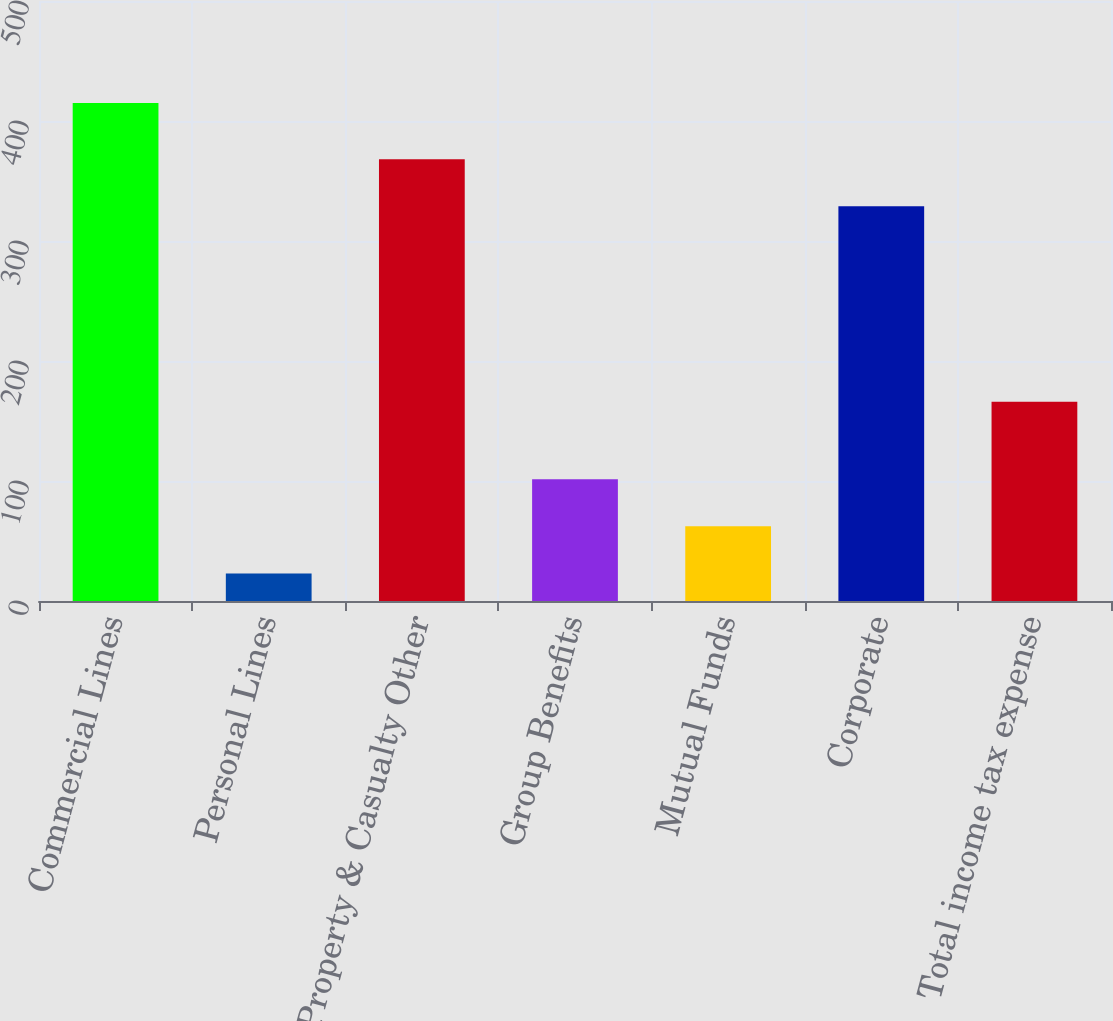Convert chart to OTSL. <chart><loc_0><loc_0><loc_500><loc_500><bar_chart><fcel>Commercial Lines<fcel>Personal Lines<fcel>Property & Casualty Other<fcel>Group Benefits<fcel>Mutual Funds<fcel>Corporate<fcel>Total income tax expense<nl><fcel>415<fcel>23<fcel>368.2<fcel>101.4<fcel>62.2<fcel>329<fcel>166<nl></chart> 